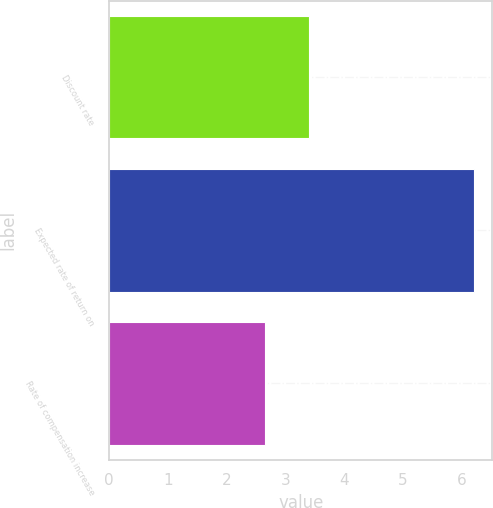<chart> <loc_0><loc_0><loc_500><loc_500><bar_chart><fcel>Discount rate<fcel>Expected rate of return on<fcel>Rate of compensation increase<nl><fcel>3.4<fcel>6.21<fcel>2.66<nl></chart> 